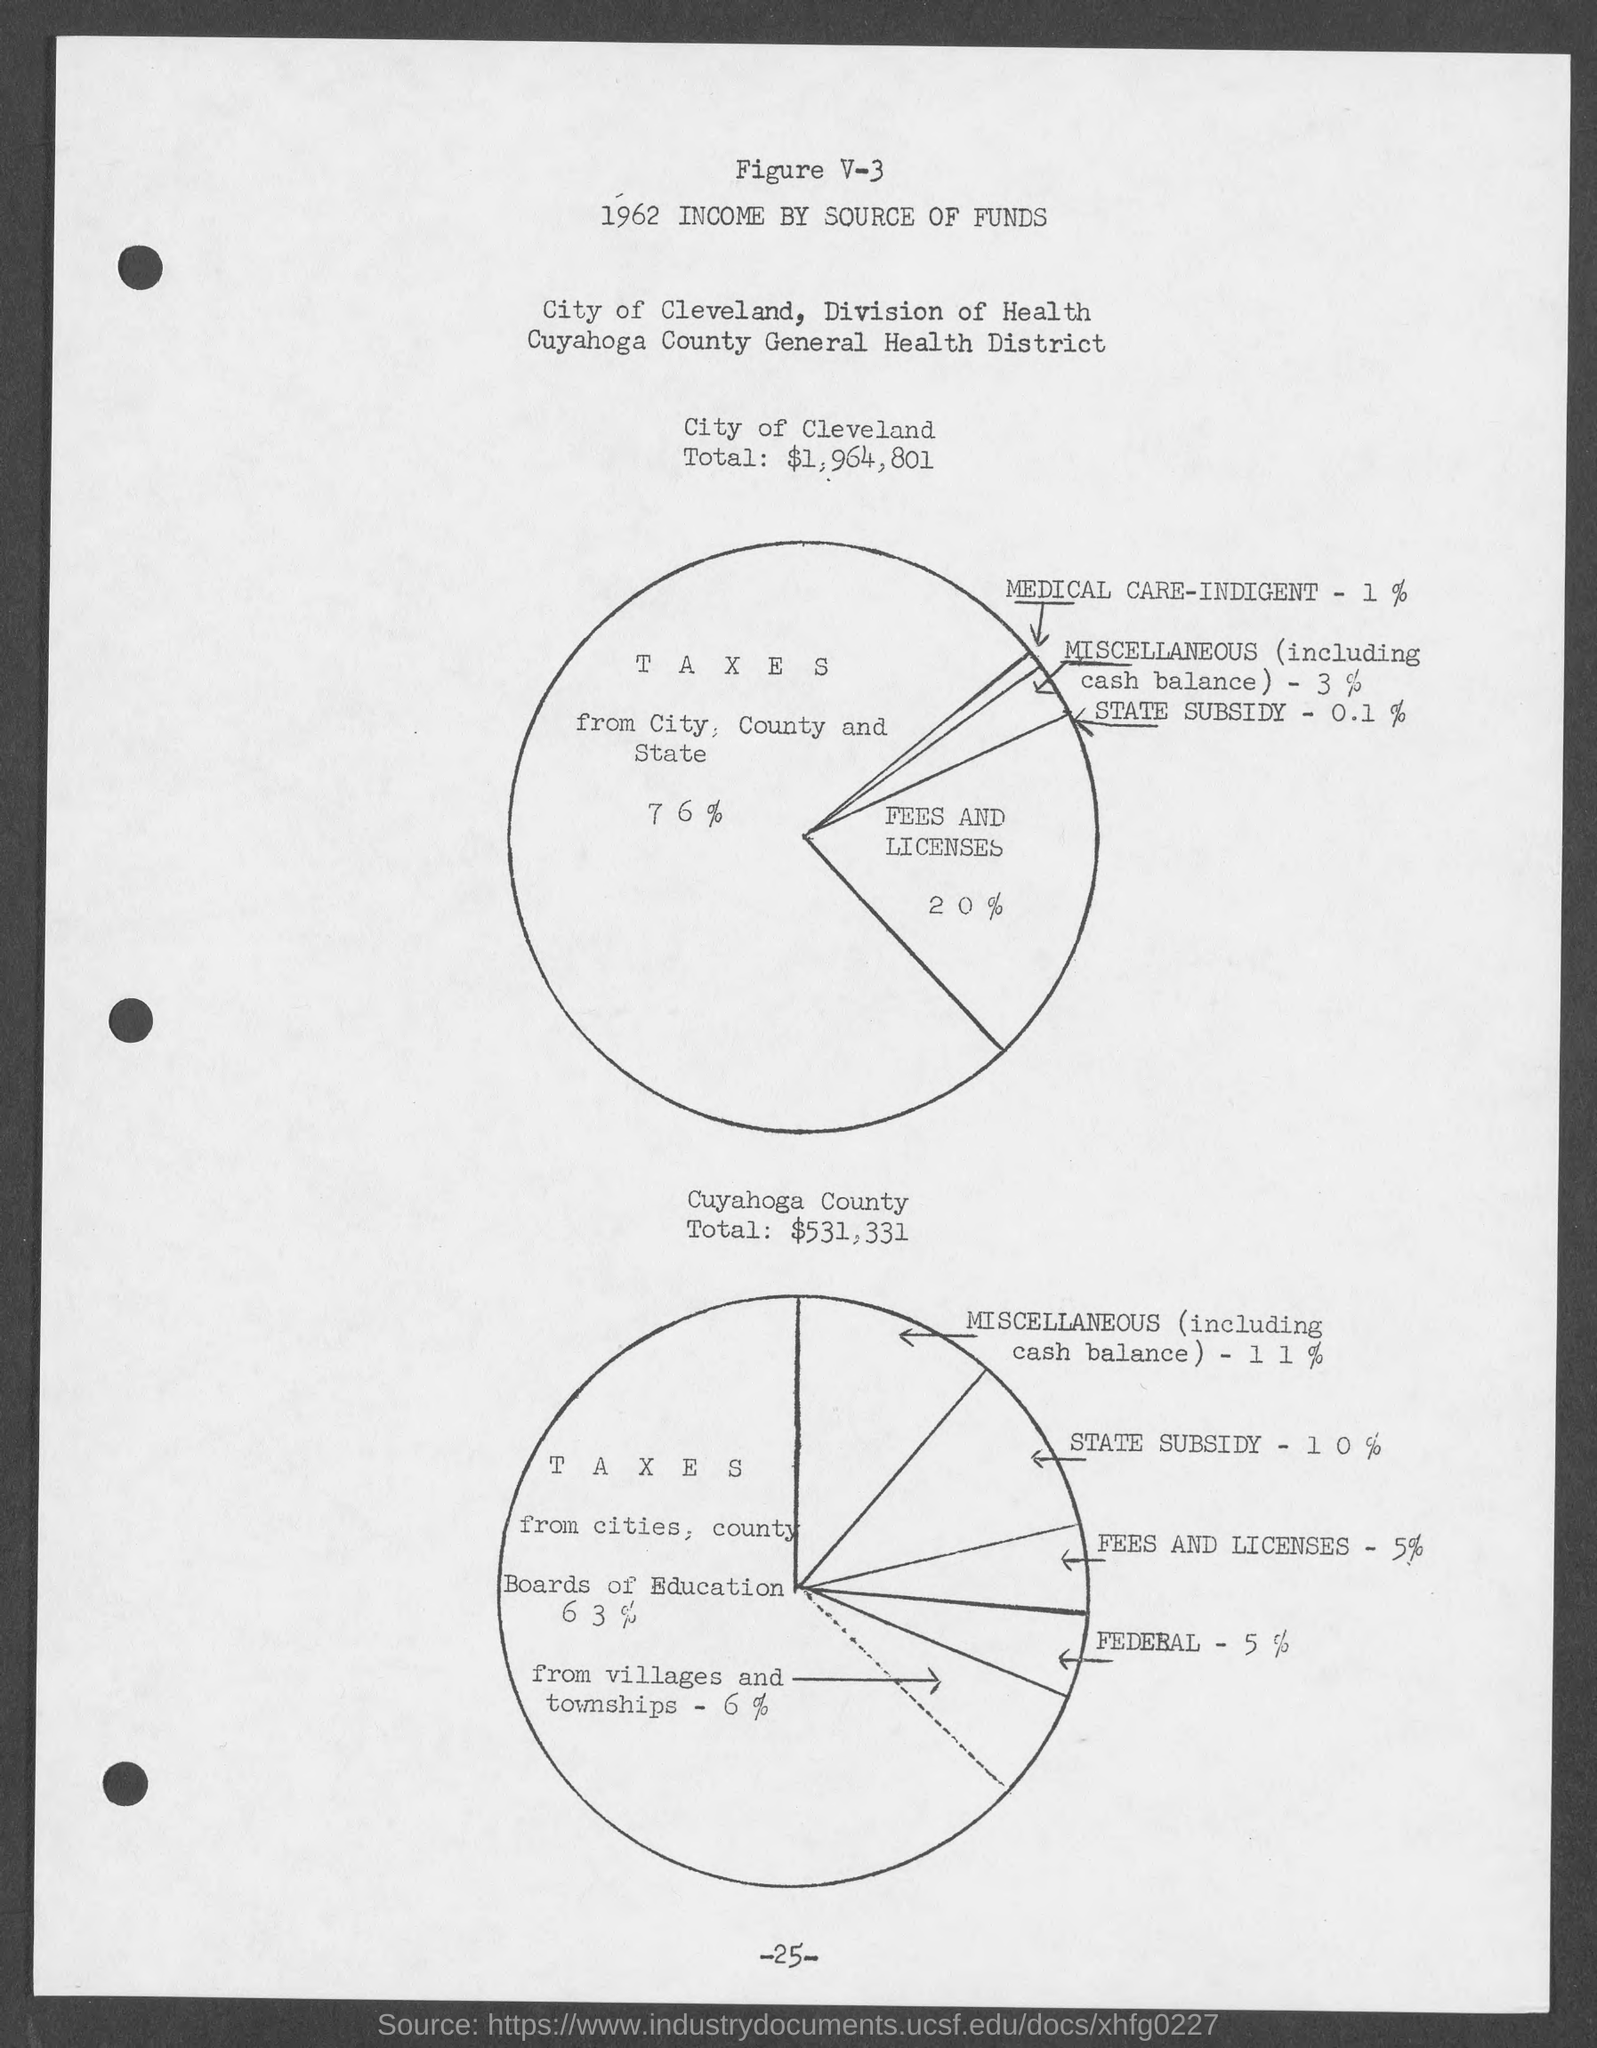What is the city of cleveland total ?
Make the answer very short. $1,964,801. What is the cuyahoga county total?
Your answer should be compact. $531,331. What is the number at bottom of the page ?
Offer a very short reply. -25-. 